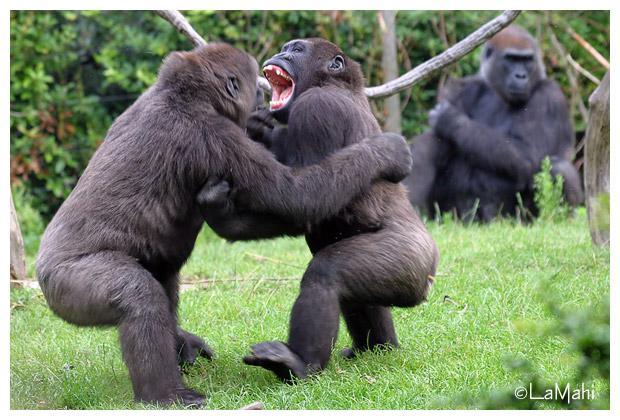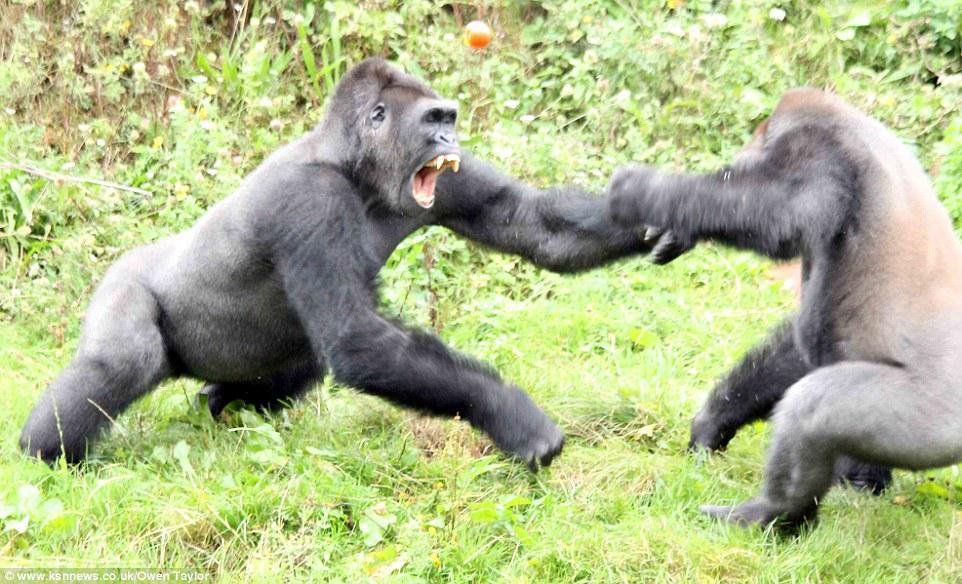The first image is the image on the left, the second image is the image on the right. Given the left and right images, does the statement "Two animals are standing up in each of the images." hold true? Answer yes or no. Yes. The first image is the image on the left, the second image is the image on the right. Analyze the images presented: Is the assertion "In each image, two male gorillas stand facing each other, with one gorilla baring its fangs with wide-open mouth." valid? Answer yes or no. Yes. 